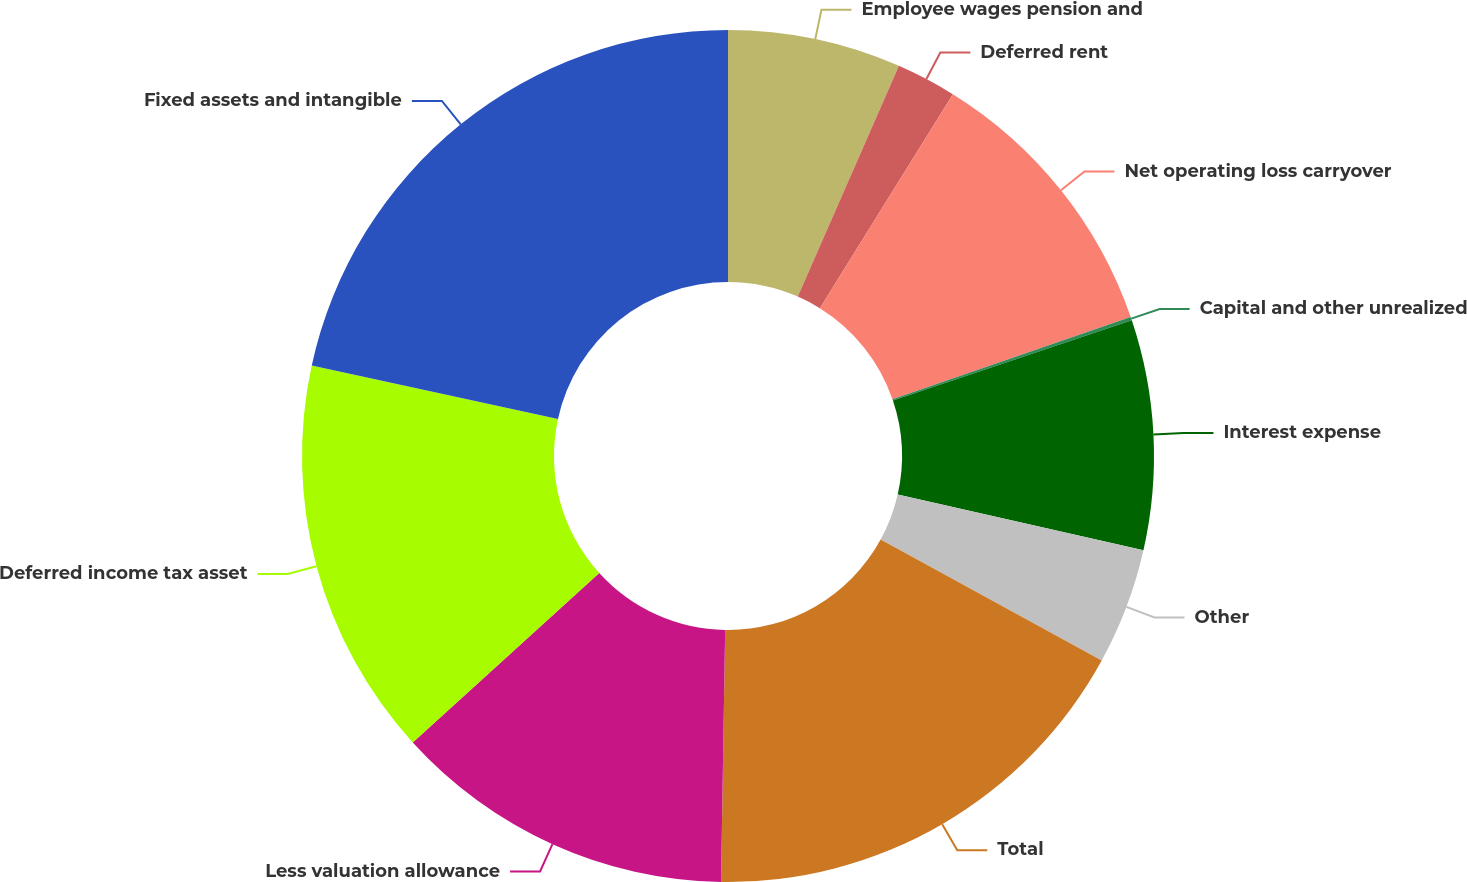Convert chart. <chart><loc_0><loc_0><loc_500><loc_500><pie_chart><fcel>Employee wages pension and<fcel>Deferred rent<fcel>Net operating loss carryover<fcel>Capital and other unrealized<fcel>Interest expense<fcel>Other<fcel>Total<fcel>Less valuation allowance<fcel>Deferred income tax asset<fcel>Fixed assets and intangible<nl><fcel>6.57%<fcel>2.28%<fcel>10.86%<fcel>0.13%<fcel>8.71%<fcel>4.42%<fcel>17.29%<fcel>13.0%<fcel>15.15%<fcel>21.59%<nl></chart> 